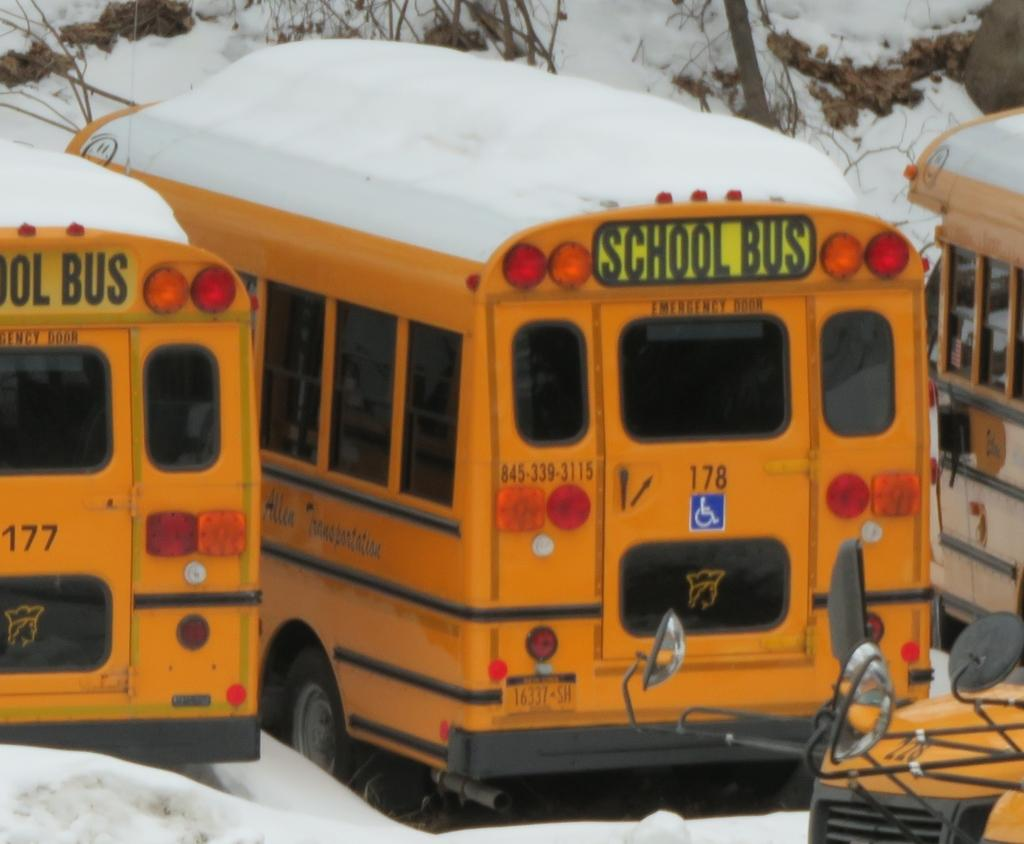What type of vehicles are present in the image? There are buses in the image. How are the buses positioned in the image? The buses are placed on the ground. What is the weather condition in the image? There is snow visible in the image. What can be seen in the background of the image? There are branches of trees in the background of the image. What type of government assistance is available for the buses in the image? There is no information about government assistance in the image, as it only shows buses, snow, and branches of trees. 